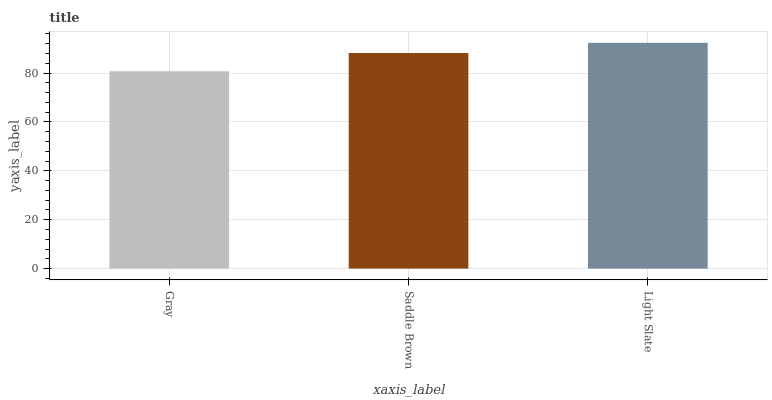Is Gray the minimum?
Answer yes or no. Yes. Is Light Slate the maximum?
Answer yes or no. Yes. Is Saddle Brown the minimum?
Answer yes or no. No. Is Saddle Brown the maximum?
Answer yes or no. No. Is Saddle Brown greater than Gray?
Answer yes or no. Yes. Is Gray less than Saddle Brown?
Answer yes or no. Yes. Is Gray greater than Saddle Brown?
Answer yes or no. No. Is Saddle Brown less than Gray?
Answer yes or no. No. Is Saddle Brown the high median?
Answer yes or no. Yes. Is Saddle Brown the low median?
Answer yes or no. Yes. Is Gray the high median?
Answer yes or no. No. Is Gray the low median?
Answer yes or no. No. 